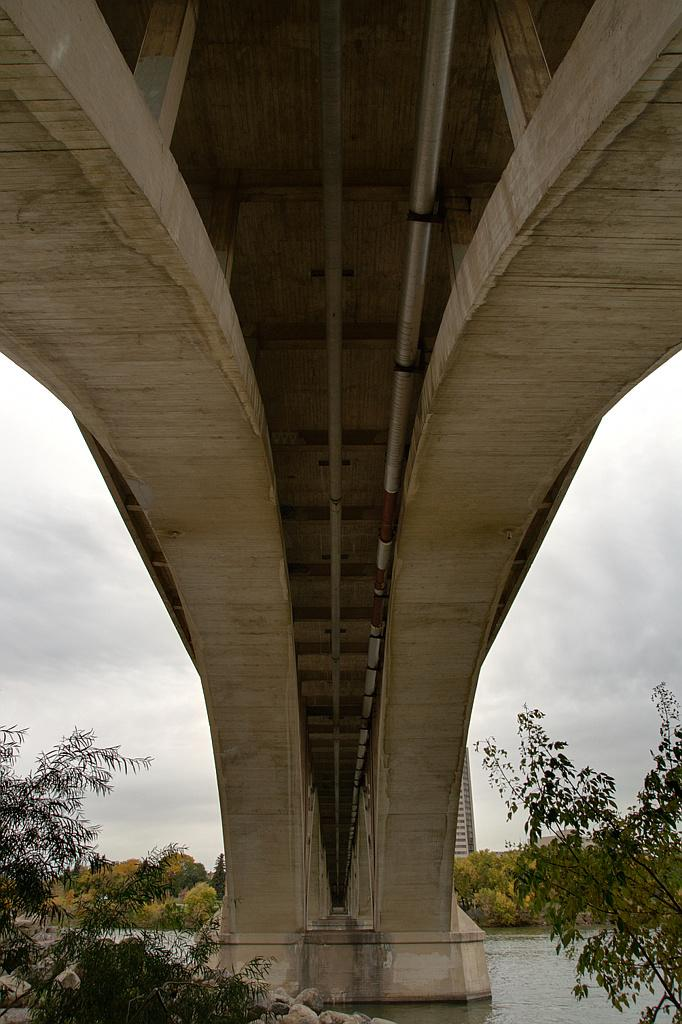What type of natural feature is at the bottom of the image? There is a river at the bottom of the image. What else can be seen at the bottom of the image? There are trees at the bottom of the image. What structure is in the center of the image? There is a bridge in the center of the image. What is visible in the background of the image? The sky is visible in the background of the image. Can you see any cherries hanging from the trees in the image? There are no cherries visible in the image; the trees are not described as having cherries. Is there a monkey swinging from the bridge in the image? There is no monkey present in the image; only the river, trees, bridge, and sky are visible. 